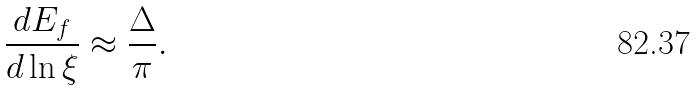<formula> <loc_0><loc_0><loc_500><loc_500>\frac { d E _ { f } } { d \ln \xi } \approx \frac { \Delta } { \pi } .</formula> 